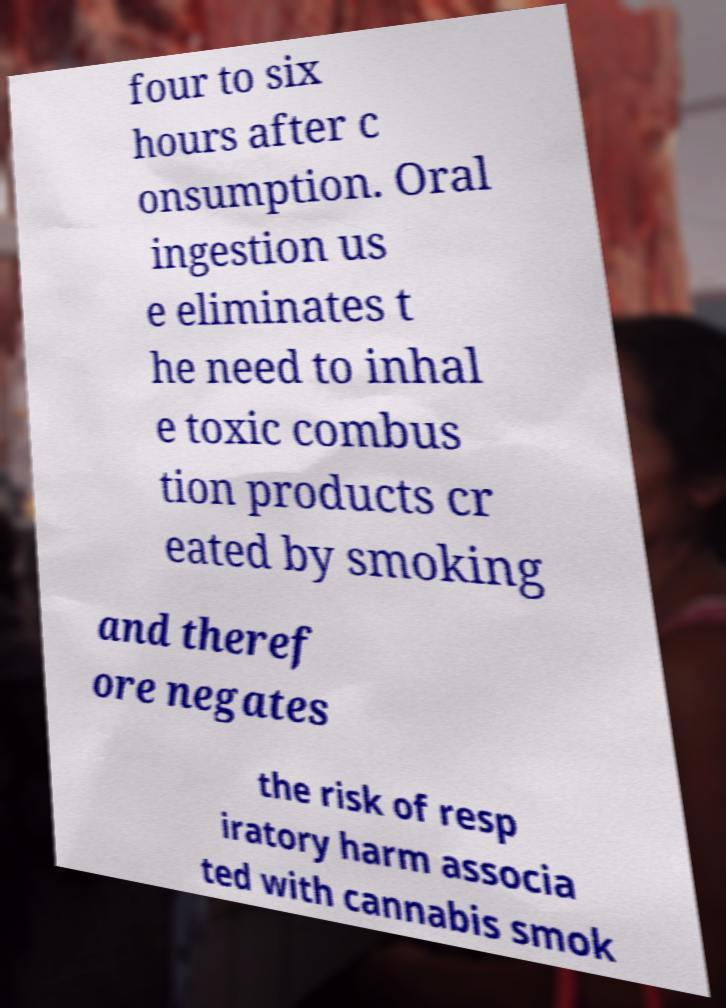Could you extract and type out the text from this image? four to six hours after c onsumption. Oral ingestion us e eliminates t he need to inhal e toxic combus tion products cr eated by smoking and theref ore negates the risk of resp iratory harm associa ted with cannabis smok 